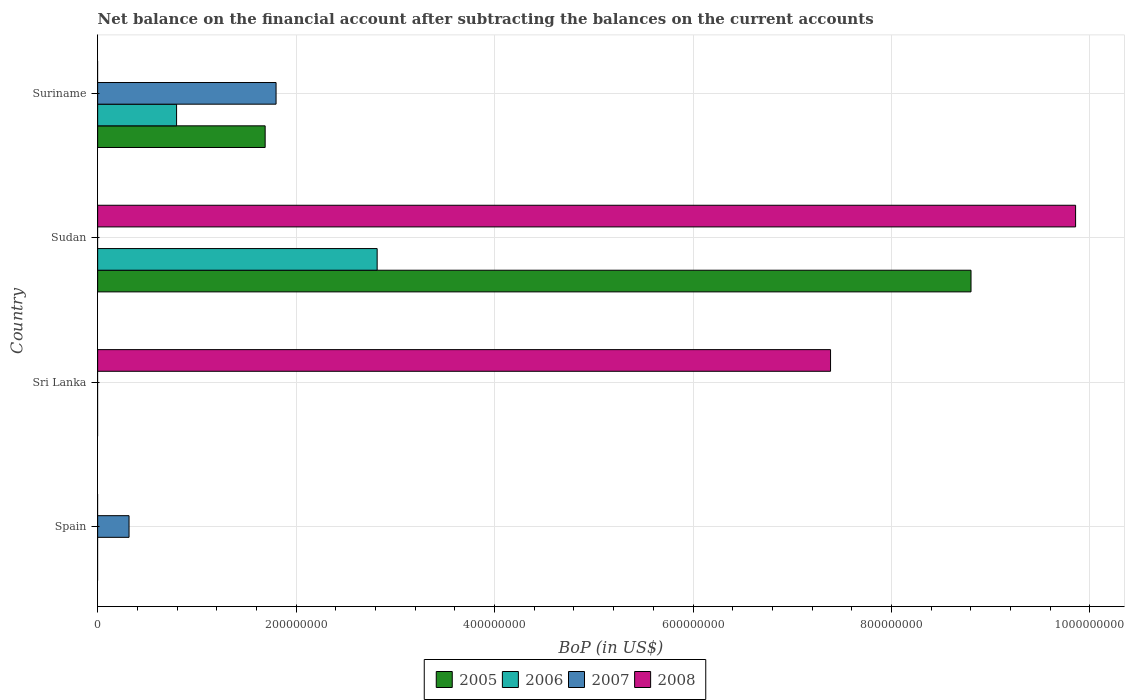Are the number of bars on each tick of the Y-axis equal?
Provide a short and direct response. No. What is the label of the 3rd group of bars from the top?
Offer a very short reply. Sri Lanka. In how many cases, is the number of bars for a given country not equal to the number of legend labels?
Give a very brief answer. 4. What is the Balance of Payments in 2006 in Suriname?
Your response must be concise. 7.95e+07. Across all countries, what is the maximum Balance of Payments in 2005?
Provide a succinct answer. 8.80e+08. In which country was the Balance of Payments in 2008 maximum?
Offer a terse response. Sudan. What is the total Balance of Payments in 2007 in the graph?
Make the answer very short. 2.11e+08. What is the average Balance of Payments in 2005 per country?
Provide a succinct answer. 2.62e+08. What is the difference between the Balance of Payments in 2006 and Balance of Payments in 2007 in Suriname?
Offer a terse response. -1.00e+08. What is the ratio of the Balance of Payments in 2005 in Sudan to that in Suriname?
Give a very brief answer. 5.21. What is the difference between the highest and the lowest Balance of Payments in 2007?
Give a very brief answer. 1.80e+08. In how many countries, is the Balance of Payments in 2006 greater than the average Balance of Payments in 2006 taken over all countries?
Provide a short and direct response. 1. Are all the bars in the graph horizontal?
Make the answer very short. Yes. How many countries are there in the graph?
Ensure brevity in your answer.  4. What is the difference between two consecutive major ticks on the X-axis?
Provide a short and direct response. 2.00e+08. Does the graph contain any zero values?
Provide a short and direct response. Yes. Does the graph contain grids?
Ensure brevity in your answer.  Yes. Where does the legend appear in the graph?
Ensure brevity in your answer.  Bottom center. How many legend labels are there?
Provide a short and direct response. 4. How are the legend labels stacked?
Your answer should be very brief. Horizontal. What is the title of the graph?
Make the answer very short. Net balance on the financial account after subtracting the balances on the current accounts. Does "1994" appear as one of the legend labels in the graph?
Your answer should be very brief. No. What is the label or title of the X-axis?
Keep it short and to the point. BoP (in US$). What is the label or title of the Y-axis?
Your response must be concise. Country. What is the BoP (in US$) of 2005 in Spain?
Provide a short and direct response. 0. What is the BoP (in US$) in 2007 in Spain?
Your response must be concise. 3.16e+07. What is the BoP (in US$) in 2008 in Spain?
Make the answer very short. 0. What is the BoP (in US$) of 2005 in Sri Lanka?
Offer a very short reply. 0. What is the BoP (in US$) of 2007 in Sri Lanka?
Your answer should be compact. 0. What is the BoP (in US$) of 2008 in Sri Lanka?
Keep it short and to the point. 7.39e+08. What is the BoP (in US$) in 2005 in Sudan?
Offer a terse response. 8.80e+08. What is the BoP (in US$) in 2006 in Sudan?
Offer a terse response. 2.82e+08. What is the BoP (in US$) of 2008 in Sudan?
Your answer should be very brief. 9.86e+08. What is the BoP (in US$) in 2005 in Suriname?
Keep it short and to the point. 1.69e+08. What is the BoP (in US$) in 2006 in Suriname?
Provide a succinct answer. 7.95e+07. What is the BoP (in US$) of 2007 in Suriname?
Give a very brief answer. 1.80e+08. What is the BoP (in US$) of 2008 in Suriname?
Offer a terse response. 0. Across all countries, what is the maximum BoP (in US$) of 2005?
Your answer should be compact. 8.80e+08. Across all countries, what is the maximum BoP (in US$) of 2006?
Give a very brief answer. 2.82e+08. Across all countries, what is the maximum BoP (in US$) in 2007?
Offer a terse response. 1.80e+08. Across all countries, what is the maximum BoP (in US$) in 2008?
Your answer should be very brief. 9.86e+08. Across all countries, what is the minimum BoP (in US$) in 2007?
Provide a succinct answer. 0. Across all countries, what is the minimum BoP (in US$) of 2008?
Give a very brief answer. 0. What is the total BoP (in US$) of 2005 in the graph?
Give a very brief answer. 1.05e+09. What is the total BoP (in US$) in 2006 in the graph?
Your answer should be very brief. 3.61e+08. What is the total BoP (in US$) in 2007 in the graph?
Your response must be concise. 2.11e+08. What is the total BoP (in US$) of 2008 in the graph?
Give a very brief answer. 1.72e+09. What is the difference between the BoP (in US$) in 2007 in Spain and that in Suriname?
Your answer should be compact. -1.48e+08. What is the difference between the BoP (in US$) in 2008 in Sri Lanka and that in Sudan?
Offer a terse response. -2.47e+08. What is the difference between the BoP (in US$) in 2005 in Sudan and that in Suriname?
Give a very brief answer. 7.11e+08. What is the difference between the BoP (in US$) of 2006 in Sudan and that in Suriname?
Provide a short and direct response. 2.02e+08. What is the difference between the BoP (in US$) in 2007 in Spain and the BoP (in US$) in 2008 in Sri Lanka?
Your answer should be very brief. -7.07e+08. What is the difference between the BoP (in US$) of 2007 in Spain and the BoP (in US$) of 2008 in Sudan?
Ensure brevity in your answer.  -9.54e+08. What is the difference between the BoP (in US$) in 2005 in Sudan and the BoP (in US$) in 2006 in Suriname?
Your answer should be very brief. 8.01e+08. What is the difference between the BoP (in US$) of 2005 in Sudan and the BoP (in US$) of 2007 in Suriname?
Offer a very short reply. 7.00e+08. What is the difference between the BoP (in US$) in 2006 in Sudan and the BoP (in US$) in 2007 in Suriname?
Your answer should be compact. 1.02e+08. What is the average BoP (in US$) of 2005 per country?
Ensure brevity in your answer.  2.62e+08. What is the average BoP (in US$) in 2006 per country?
Your response must be concise. 9.03e+07. What is the average BoP (in US$) in 2007 per country?
Offer a terse response. 5.29e+07. What is the average BoP (in US$) of 2008 per country?
Make the answer very short. 4.31e+08. What is the difference between the BoP (in US$) in 2005 and BoP (in US$) in 2006 in Sudan?
Provide a short and direct response. 5.98e+08. What is the difference between the BoP (in US$) of 2005 and BoP (in US$) of 2008 in Sudan?
Provide a succinct answer. -1.05e+08. What is the difference between the BoP (in US$) of 2006 and BoP (in US$) of 2008 in Sudan?
Make the answer very short. -7.04e+08. What is the difference between the BoP (in US$) in 2005 and BoP (in US$) in 2006 in Suriname?
Provide a succinct answer. 8.93e+07. What is the difference between the BoP (in US$) in 2005 and BoP (in US$) in 2007 in Suriname?
Keep it short and to the point. -1.10e+07. What is the difference between the BoP (in US$) in 2006 and BoP (in US$) in 2007 in Suriname?
Provide a succinct answer. -1.00e+08. What is the ratio of the BoP (in US$) of 2007 in Spain to that in Suriname?
Offer a very short reply. 0.18. What is the ratio of the BoP (in US$) in 2008 in Sri Lanka to that in Sudan?
Provide a short and direct response. 0.75. What is the ratio of the BoP (in US$) in 2005 in Sudan to that in Suriname?
Your answer should be compact. 5.21. What is the ratio of the BoP (in US$) in 2006 in Sudan to that in Suriname?
Provide a short and direct response. 3.54. What is the difference between the highest and the lowest BoP (in US$) of 2005?
Offer a very short reply. 8.80e+08. What is the difference between the highest and the lowest BoP (in US$) in 2006?
Give a very brief answer. 2.82e+08. What is the difference between the highest and the lowest BoP (in US$) of 2007?
Keep it short and to the point. 1.80e+08. What is the difference between the highest and the lowest BoP (in US$) in 2008?
Make the answer very short. 9.86e+08. 